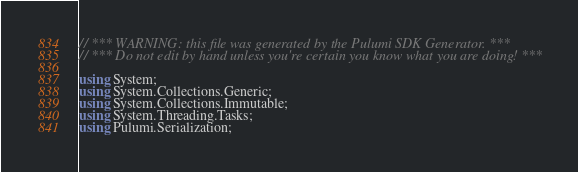Convert code to text. <code><loc_0><loc_0><loc_500><loc_500><_C#_>// *** WARNING: this file was generated by the Pulumi SDK Generator. ***
// *** Do not edit by hand unless you're certain you know what you are doing! ***

using System;
using System.Collections.Generic;
using System.Collections.Immutable;
using System.Threading.Tasks;
using Pulumi.Serialization;
</code> 